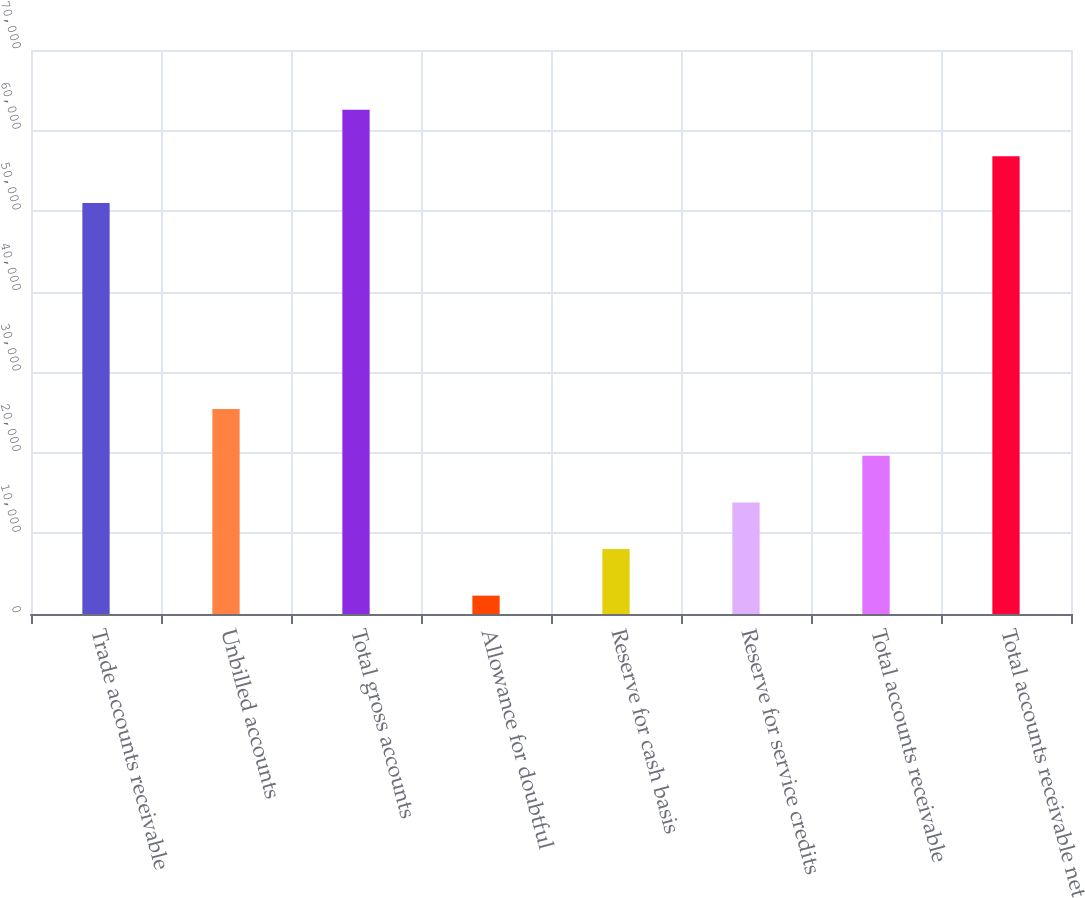Convert chart. <chart><loc_0><loc_0><loc_500><loc_500><bar_chart><fcel>Trade accounts receivable<fcel>Unbilled accounts<fcel>Total gross accounts<fcel>Allowance for doubtful<fcel>Reserve for cash basis<fcel>Reserve for service credits<fcel>Total accounts receivable<fcel>Total accounts receivable net<nl><fcel>51019<fcel>25428.6<fcel>62594.8<fcel>2277<fcel>8064.9<fcel>13852.8<fcel>19640.7<fcel>56806.9<nl></chart> 